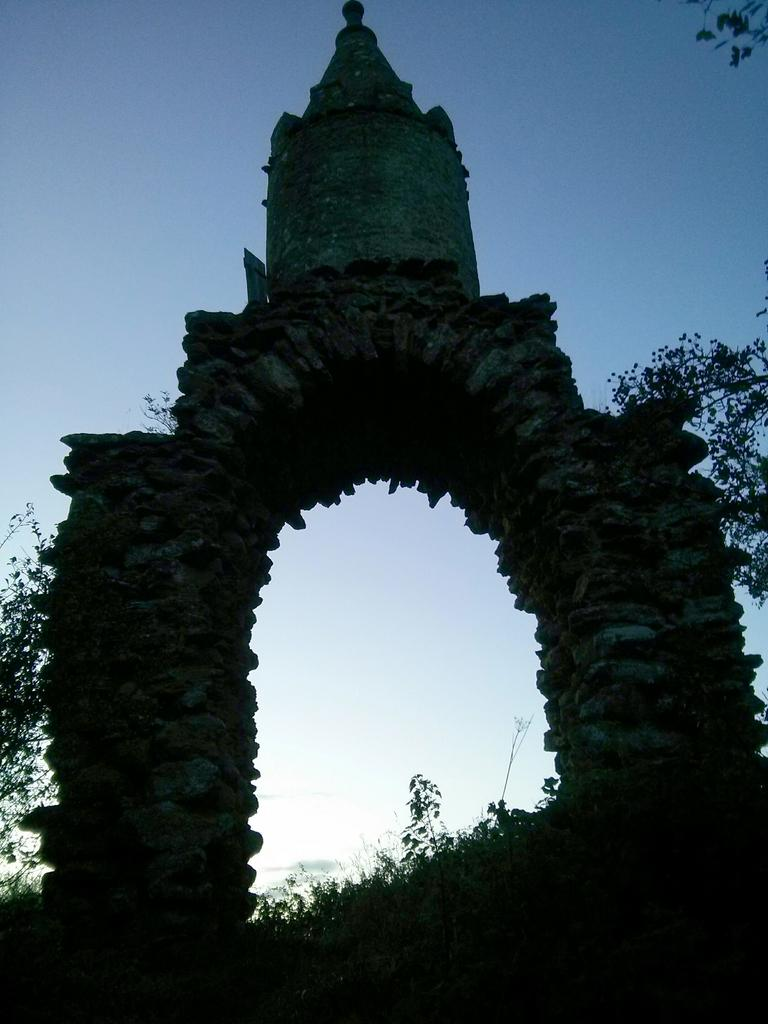What is the main structure in the center of the image? There is an arch in the center of the image. What can be seen in the background of the image? There are trees and the sky visible in the background of the image. How many pies are on the arch in the image? There are no pies present in the image; it features an arch with no pies on it. Can you tell me where the grandmother is sitting in the image? There is no grandmother present in the image. 